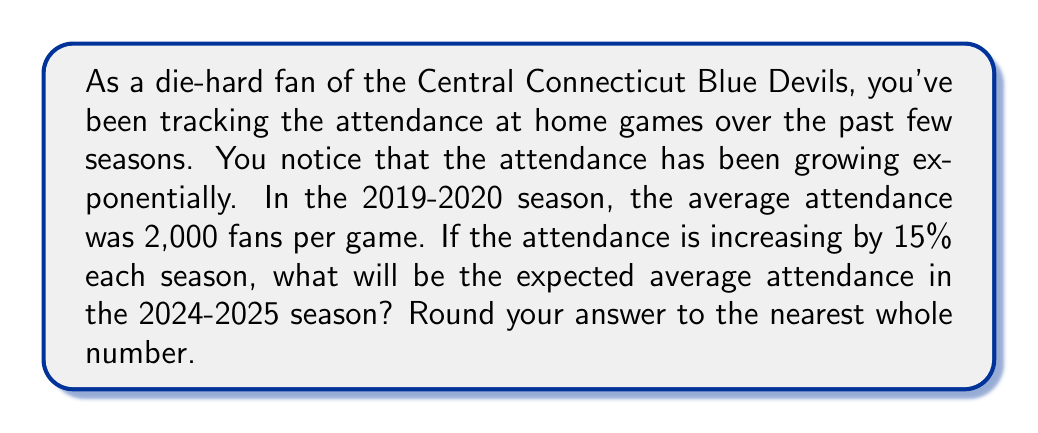Show me your answer to this math problem. Let's approach this problem step-by-step:

1) We start with an initial attendance of 2,000 fans in the 2019-2020 season.
2) The attendance is growing by 15% (or 1.15 times) each season.
3) We need to calculate the attendance after 5 seasons (from 2019-2020 to 2024-2025).

We can use the exponential growth formula:

$$A = P(1 + r)^n$$

Where:
$A$ = Final amount
$P$ = Initial principal balance
$r$ = Growth rate (as a decimal)
$n$ = Number of time periods

In our case:
$P = 2000$
$r = 0.15$ (15% expressed as a decimal)
$n = 5$ (5 seasons of growth)

Let's plug these values into our formula:

$$A = 2000(1 + 0.15)^5$$
$$A = 2000(1.15)^5$$

Now let's calculate:

$$A = 2000 * 2.0113689$$
$$A = 4022.7378$$

Rounding to the nearest whole number:

$$A ≈ 4023$$
Answer: 4,023 fans 